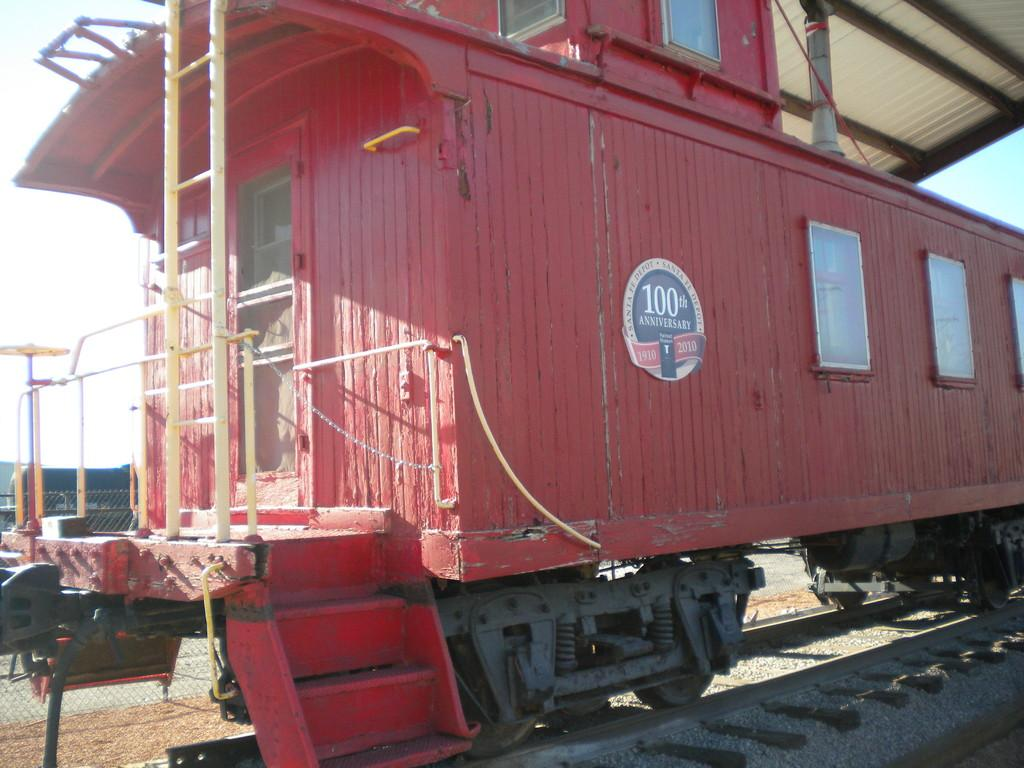What is the main subject of the image? The main subject of the image is a train bogie on the tracks. What additional object can be seen in the image? A: There is a ladder visible in the image. What type of material is present in the image? There is mesh visible in the image. What is visible in the background of the image? The sky is visible in the image. What type of polish is being applied to the train bogie in the image? There is no indication in the image that any polish is being applied to the train bogie. 